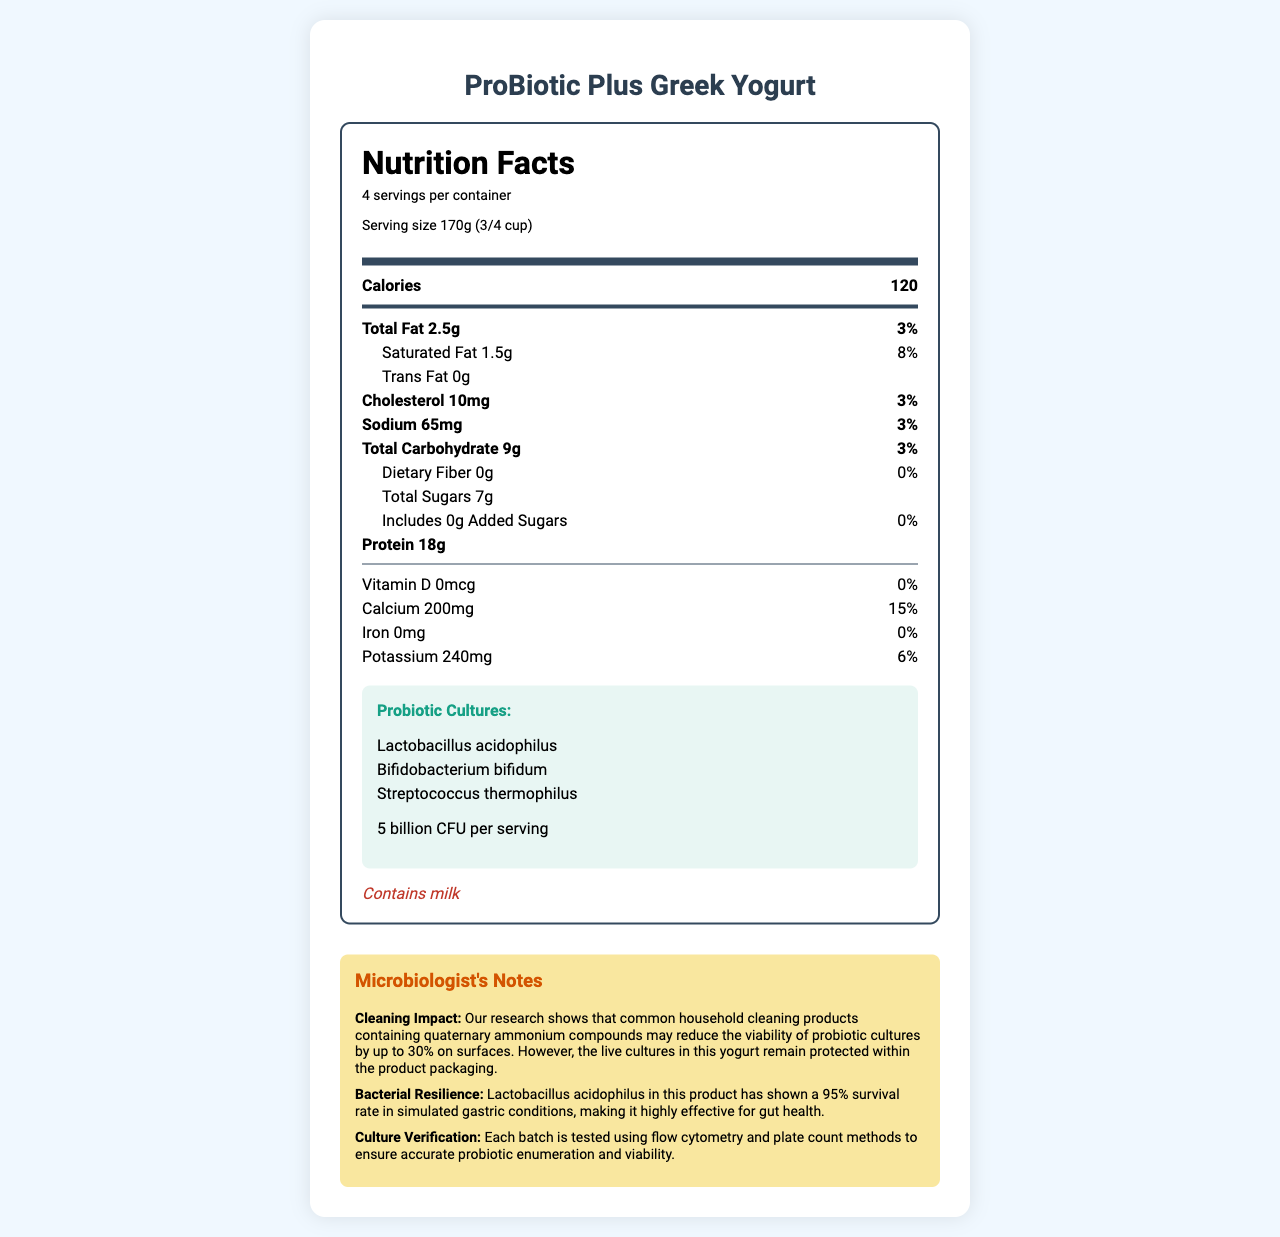what is the total fat content per serving? The nutrition label specifies that the Total Fat content per serving is 2.5g.
Answer: 2.5g how many servings are there per container? The document states that there are 4 servings per container.
Answer: 4 what type of probiotic cultures are present in this yogurt? These probiotic cultures are listed under the "Probiotic Cultures" section.
Answer: Lactobacillus acidophilus, Bifidobacterium bifidum, Streptococcus thermophilus what is the serving size of this yogurt? The serving size is mentioned specifically as 170g (3/4 cup).
Answer: 170g (3/4 cup) how many calories are there per serving? The label clearly shows that there are 120 calories per serving.
Answer: 120 what is the percentage daily value of calcium? A. 5% B. 10% C. 15% The percent daily value of calcium is listed as 15%.
Answer: C. 15% which cleaning compounds may reduce the viability of probiotic cultures by up to 30%? A. Alcohol B. Quaternary ammonium compounds C. Bleach The microbiologist notes specify that quaternary ammonium compounds may reduce the viability of probiotic cultures by up to 30%.
Answer: B. Quaternary ammonium compounds does this yogurt contain any added sugars? The label lists 0g of added sugars, meaning there are no added sugars in this yogurt.
Answer: No is there vitamin D in this yogurt? The label indicates 0mcg of Vitamin D, meaning it contains no Vitamin D.
Answer: No summarize the primary purpose of this document. This document is a comprehensive guide to the nutritional and probiotic content of the ProBiotic Plus Greek Yogurt, along with helpful insights about the microbiologist's findings.
Answer: The document provides the nutrition facts label for a probiotic Greek yogurt, highlighting key nutritional information, probiotic content, allergen information, and microbiologist notes on cleaning impact and bacterial resilience. what is the source of protein in this yogurt? The document does not specify the exact source of protein in the yogurt.
Answer: Not enough information 